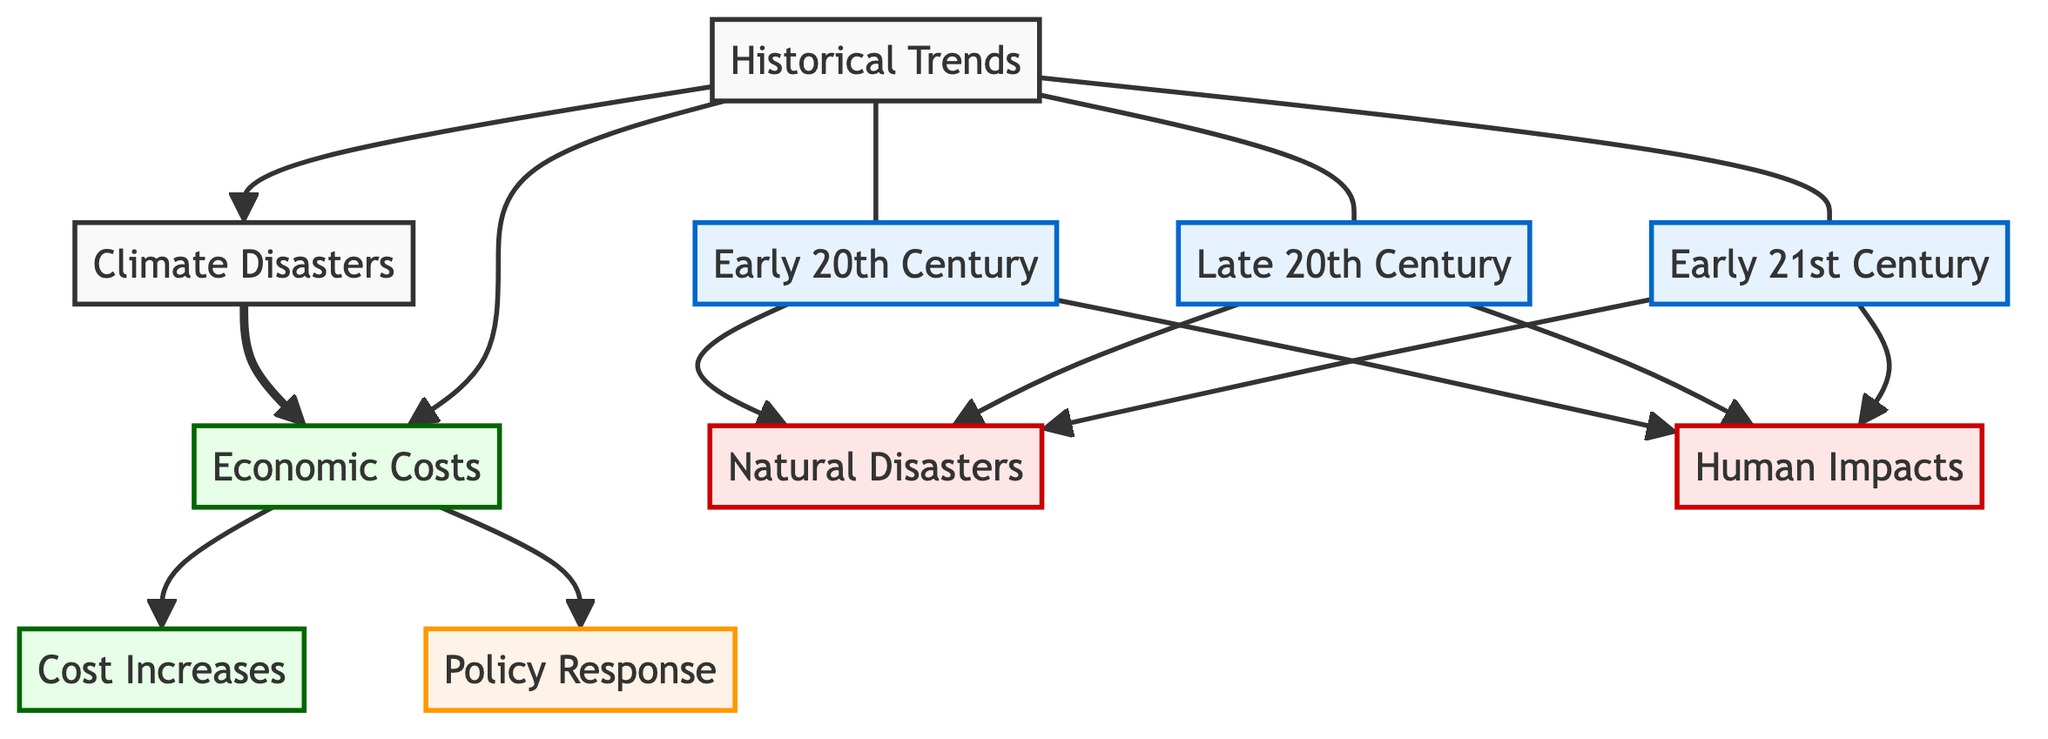What are the three periods highlighted in the historical trends? The diagram lists three periods: Early 20th Century, Late 20th Century, and Early 21st Century. These can be found as individual nodes connected to the "Historical Trends" node, indicating key times of interest.
Answer: Early 20th Century, Late 20th Century, Early 21st Century How many nodes are in the impact category of the diagram? The impact category consists of two nodes: Natural Disasters and Human Impacts. By counting the nodes classified under this category, we can see there are a total of two.
Answer: 2 What is the relationship between climate disasters and economic costs? The diagram shows a direct influence where "Climate Disasters" leads to "Economic Costs". This suggests that as climate disasters occur, they directly contribute to increasing economic costs.
Answer: Direct influence Which period has connections to all natural disasters and human impacts? Each of the periods: Early 20th Century, Late 20th Century, and Early 21st Century has connections to both Natural Disasters and Human Impacts, which can be identified by tracing the arrows leading from each period's nodes.
Answer: All three periods What leads to cost increases as per the diagram? The diagram indicates that "Economic Costs" leads directly to "Cost Increases". By following the flow starting from economic costs, we can see how they escalate over time due to various factors.
Answer: Economic Costs What type of response is indicated under the economic costs category? The diagram specifies "Policy Response" as a direct result of "Economic Costs". This suggests that as economic costs rise, there are subsequent policy responses aimed at addressing them.
Answer: Policy Response Which nodes are classified under the cost category? The cost category includes "Economic Costs" and "Cost Increases". These nodes are visually distinguished in the diagram and represent economic implications related to climate disasters.
Answer: Economic Costs, Cost Increases How does the Early 20th Century relate to human impacts according to the diagram? The diagram shows that the Early 20th Century has a direct connection to "Human Impacts". This indicates that during this period, there were significant human impacts triggered by climate-related events.
Answer: Direct connection 